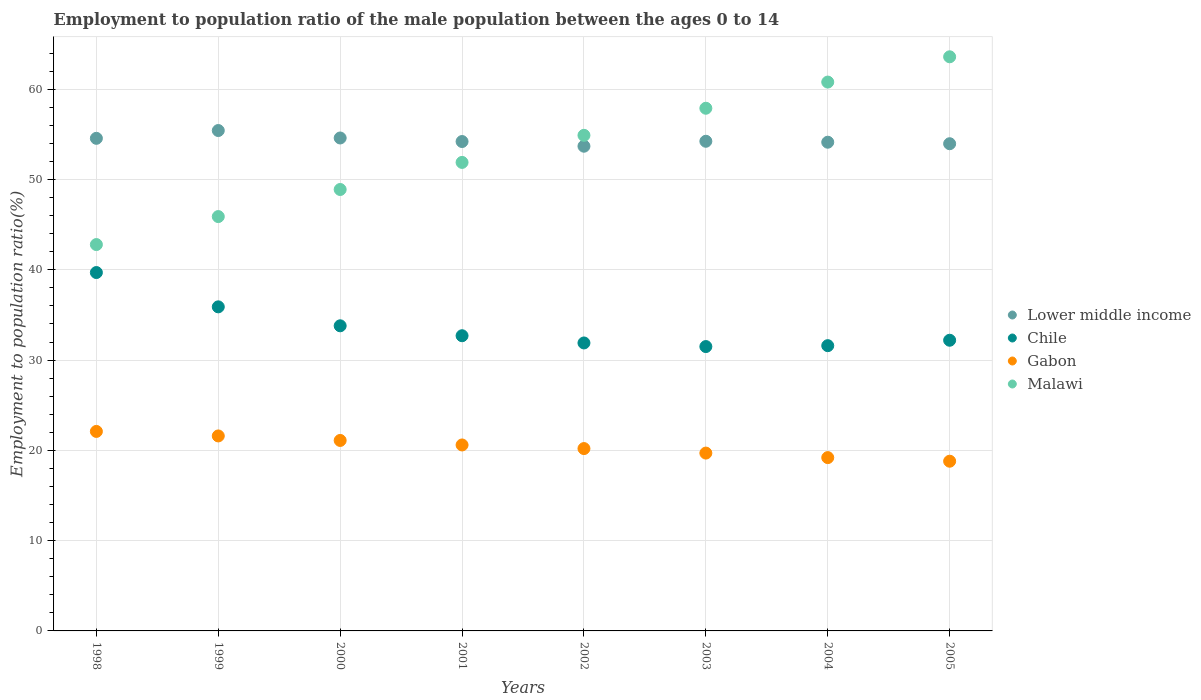How many different coloured dotlines are there?
Offer a very short reply. 4. Is the number of dotlines equal to the number of legend labels?
Keep it short and to the point. Yes. What is the employment to population ratio in Chile in 2002?
Your answer should be very brief. 31.9. Across all years, what is the maximum employment to population ratio in Chile?
Provide a succinct answer. 39.7. Across all years, what is the minimum employment to population ratio in Gabon?
Your response must be concise. 18.8. In which year was the employment to population ratio in Chile maximum?
Provide a short and direct response. 1998. What is the total employment to population ratio in Malawi in the graph?
Give a very brief answer. 426.7. What is the difference between the employment to population ratio in Gabon in 2002 and that in 2005?
Provide a succinct answer. 1.4. What is the difference between the employment to population ratio in Chile in 1999 and the employment to population ratio in Gabon in 2005?
Provide a short and direct response. 17.1. What is the average employment to population ratio in Chile per year?
Your answer should be compact. 33.66. In the year 2002, what is the difference between the employment to population ratio in Lower middle income and employment to population ratio in Gabon?
Keep it short and to the point. 33.49. What is the ratio of the employment to population ratio in Lower middle income in 1999 to that in 2002?
Your response must be concise. 1.03. Is the employment to population ratio in Lower middle income in 1998 less than that in 2001?
Offer a terse response. No. Is the difference between the employment to population ratio in Lower middle income in 1999 and 2001 greater than the difference between the employment to population ratio in Gabon in 1999 and 2001?
Provide a succinct answer. Yes. What is the difference between the highest and the second highest employment to population ratio in Lower middle income?
Your response must be concise. 0.83. What is the difference between the highest and the lowest employment to population ratio in Chile?
Ensure brevity in your answer.  8.2. In how many years, is the employment to population ratio in Chile greater than the average employment to population ratio in Chile taken over all years?
Ensure brevity in your answer.  3. Is it the case that in every year, the sum of the employment to population ratio in Gabon and employment to population ratio in Malawi  is greater than the sum of employment to population ratio in Lower middle income and employment to population ratio in Chile?
Give a very brief answer. Yes. Is it the case that in every year, the sum of the employment to population ratio in Gabon and employment to population ratio in Malawi  is greater than the employment to population ratio in Chile?
Offer a terse response. Yes. Does the employment to population ratio in Malawi monotonically increase over the years?
Keep it short and to the point. Yes. Is the employment to population ratio in Gabon strictly greater than the employment to population ratio in Lower middle income over the years?
Make the answer very short. No. How many dotlines are there?
Provide a succinct answer. 4. How many years are there in the graph?
Provide a short and direct response. 8. Does the graph contain any zero values?
Ensure brevity in your answer.  No. What is the title of the graph?
Ensure brevity in your answer.  Employment to population ratio of the male population between the ages 0 to 14. Does "St. Martin (French part)" appear as one of the legend labels in the graph?
Your response must be concise. No. What is the label or title of the X-axis?
Ensure brevity in your answer.  Years. What is the Employment to population ratio(%) of Lower middle income in 1998?
Give a very brief answer. 54.57. What is the Employment to population ratio(%) in Chile in 1998?
Give a very brief answer. 39.7. What is the Employment to population ratio(%) in Gabon in 1998?
Keep it short and to the point. 22.1. What is the Employment to population ratio(%) of Malawi in 1998?
Provide a succinct answer. 42.8. What is the Employment to population ratio(%) of Lower middle income in 1999?
Offer a terse response. 55.43. What is the Employment to population ratio(%) in Chile in 1999?
Provide a succinct answer. 35.9. What is the Employment to population ratio(%) of Gabon in 1999?
Your answer should be very brief. 21.6. What is the Employment to population ratio(%) in Malawi in 1999?
Offer a very short reply. 45.9. What is the Employment to population ratio(%) in Lower middle income in 2000?
Give a very brief answer. 54.61. What is the Employment to population ratio(%) of Chile in 2000?
Offer a terse response. 33.8. What is the Employment to population ratio(%) in Gabon in 2000?
Your response must be concise. 21.1. What is the Employment to population ratio(%) in Malawi in 2000?
Make the answer very short. 48.9. What is the Employment to population ratio(%) of Lower middle income in 2001?
Offer a terse response. 54.21. What is the Employment to population ratio(%) of Chile in 2001?
Your response must be concise. 32.7. What is the Employment to population ratio(%) in Gabon in 2001?
Keep it short and to the point. 20.6. What is the Employment to population ratio(%) in Malawi in 2001?
Keep it short and to the point. 51.9. What is the Employment to population ratio(%) of Lower middle income in 2002?
Provide a succinct answer. 53.69. What is the Employment to population ratio(%) in Chile in 2002?
Your answer should be very brief. 31.9. What is the Employment to population ratio(%) in Gabon in 2002?
Offer a terse response. 20.2. What is the Employment to population ratio(%) in Malawi in 2002?
Provide a short and direct response. 54.9. What is the Employment to population ratio(%) of Lower middle income in 2003?
Make the answer very short. 54.24. What is the Employment to population ratio(%) of Chile in 2003?
Your answer should be compact. 31.5. What is the Employment to population ratio(%) of Gabon in 2003?
Your answer should be compact. 19.7. What is the Employment to population ratio(%) in Malawi in 2003?
Give a very brief answer. 57.9. What is the Employment to population ratio(%) in Lower middle income in 2004?
Your response must be concise. 54.14. What is the Employment to population ratio(%) of Chile in 2004?
Your answer should be very brief. 31.6. What is the Employment to population ratio(%) in Gabon in 2004?
Your answer should be compact. 19.2. What is the Employment to population ratio(%) in Malawi in 2004?
Provide a succinct answer. 60.8. What is the Employment to population ratio(%) of Lower middle income in 2005?
Your answer should be very brief. 53.97. What is the Employment to population ratio(%) of Chile in 2005?
Give a very brief answer. 32.2. What is the Employment to population ratio(%) of Gabon in 2005?
Offer a very short reply. 18.8. What is the Employment to population ratio(%) in Malawi in 2005?
Provide a short and direct response. 63.6. Across all years, what is the maximum Employment to population ratio(%) of Lower middle income?
Your response must be concise. 55.43. Across all years, what is the maximum Employment to population ratio(%) of Chile?
Provide a succinct answer. 39.7. Across all years, what is the maximum Employment to population ratio(%) in Gabon?
Ensure brevity in your answer.  22.1. Across all years, what is the maximum Employment to population ratio(%) of Malawi?
Make the answer very short. 63.6. Across all years, what is the minimum Employment to population ratio(%) of Lower middle income?
Your answer should be very brief. 53.69. Across all years, what is the minimum Employment to population ratio(%) in Chile?
Make the answer very short. 31.5. Across all years, what is the minimum Employment to population ratio(%) of Gabon?
Your answer should be very brief. 18.8. Across all years, what is the minimum Employment to population ratio(%) in Malawi?
Give a very brief answer. 42.8. What is the total Employment to population ratio(%) in Lower middle income in the graph?
Provide a succinct answer. 434.86. What is the total Employment to population ratio(%) of Chile in the graph?
Provide a short and direct response. 269.3. What is the total Employment to population ratio(%) of Gabon in the graph?
Provide a short and direct response. 163.3. What is the total Employment to population ratio(%) of Malawi in the graph?
Ensure brevity in your answer.  426.7. What is the difference between the Employment to population ratio(%) in Lower middle income in 1998 and that in 1999?
Provide a succinct answer. -0.86. What is the difference between the Employment to population ratio(%) in Chile in 1998 and that in 1999?
Keep it short and to the point. 3.8. What is the difference between the Employment to population ratio(%) of Lower middle income in 1998 and that in 2000?
Keep it short and to the point. -0.04. What is the difference between the Employment to population ratio(%) of Lower middle income in 1998 and that in 2001?
Ensure brevity in your answer.  0.35. What is the difference between the Employment to population ratio(%) in Chile in 1998 and that in 2001?
Provide a short and direct response. 7. What is the difference between the Employment to population ratio(%) of Gabon in 1998 and that in 2001?
Provide a succinct answer. 1.5. What is the difference between the Employment to population ratio(%) of Malawi in 1998 and that in 2001?
Ensure brevity in your answer.  -9.1. What is the difference between the Employment to population ratio(%) in Lower middle income in 1998 and that in 2002?
Your response must be concise. 0.87. What is the difference between the Employment to population ratio(%) of Gabon in 1998 and that in 2002?
Ensure brevity in your answer.  1.9. What is the difference between the Employment to population ratio(%) in Lower middle income in 1998 and that in 2003?
Offer a very short reply. 0.33. What is the difference between the Employment to population ratio(%) of Chile in 1998 and that in 2003?
Provide a succinct answer. 8.2. What is the difference between the Employment to population ratio(%) in Gabon in 1998 and that in 2003?
Offer a very short reply. 2.4. What is the difference between the Employment to population ratio(%) in Malawi in 1998 and that in 2003?
Provide a succinct answer. -15.1. What is the difference between the Employment to population ratio(%) in Lower middle income in 1998 and that in 2004?
Keep it short and to the point. 0.43. What is the difference between the Employment to population ratio(%) of Gabon in 1998 and that in 2004?
Ensure brevity in your answer.  2.9. What is the difference between the Employment to population ratio(%) of Lower middle income in 1998 and that in 2005?
Keep it short and to the point. 0.6. What is the difference between the Employment to population ratio(%) in Malawi in 1998 and that in 2005?
Offer a very short reply. -20.8. What is the difference between the Employment to population ratio(%) in Lower middle income in 1999 and that in 2000?
Keep it short and to the point. 0.83. What is the difference between the Employment to population ratio(%) of Malawi in 1999 and that in 2000?
Provide a short and direct response. -3. What is the difference between the Employment to population ratio(%) in Lower middle income in 1999 and that in 2001?
Give a very brief answer. 1.22. What is the difference between the Employment to population ratio(%) of Gabon in 1999 and that in 2001?
Your response must be concise. 1. What is the difference between the Employment to population ratio(%) of Lower middle income in 1999 and that in 2002?
Ensure brevity in your answer.  1.74. What is the difference between the Employment to population ratio(%) of Chile in 1999 and that in 2002?
Your answer should be compact. 4. What is the difference between the Employment to population ratio(%) in Lower middle income in 1999 and that in 2003?
Make the answer very short. 1.19. What is the difference between the Employment to population ratio(%) of Chile in 1999 and that in 2003?
Keep it short and to the point. 4.4. What is the difference between the Employment to population ratio(%) of Gabon in 1999 and that in 2003?
Your response must be concise. 1.9. What is the difference between the Employment to population ratio(%) of Malawi in 1999 and that in 2003?
Offer a very short reply. -12. What is the difference between the Employment to population ratio(%) in Lower middle income in 1999 and that in 2004?
Give a very brief answer. 1.29. What is the difference between the Employment to population ratio(%) in Chile in 1999 and that in 2004?
Your answer should be very brief. 4.3. What is the difference between the Employment to population ratio(%) of Malawi in 1999 and that in 2004?
Make the answer very short. -14.9. What is the difference between the Employment to population ratio(%) of Lower middle income in 1999 and that in 2005?
Keep it short and to the point. 1.46. What is the difference between the Employment to population ratio(%) in Chile in 1999 and that in 2005?
Your answer should be very brief. 3.7. What is the difference between the Employment to population ratio(%) in Malawi in 1999 and that in 2005?
Keep it short and to the point. -17.7. What is the difference between the Employment to population ratio(%) in Lower middle income in 2000 and that in 2001?
Keep it short and to the point. 0.39. What is the difference between the Employment to population ratio(%) in Malawi in 2000 and that in 2001?
Offer a very short reply. -3. What is the difference between the Employment to population ratio(%) in Lower middle income in 2000 and that in 2002?
Make the answer very short. 0.91. What is the difference between the Employment to population ratio(%) in Gabon in 2000 and that in 2002?
Your response must be concise. 0.9. What is the difference between the Employment to population ratio(%) in Malawi in 2000 and that in 2002?
Your answer should be very brief. -6. What is the difference between the Employment to population ratio(%) of Lower middle income in 2000 and that in 2003?
Your answer should be compact. 0.36. What is the difference between the Employment to population ratio(%) in Gabon in 2000 and that in 2003?
Your answer should be very brief. 1.4. What is the difference between the Employment to population ratio(%) in Malawi in 2000 and that in 2003?
Make the answer very short. -9. What is the difference between the Employment to population ratio(%) in Lower middle income in 2000 and that in 2004?
Make the answer very short. 0.47. What is the difference between the Employment to population ratio(%) of Chile in 2000 and that in 2004?
Your answer should be very brief. 2.2. What is the difference between the Employment to population ratio(%) in Lower middle income in 2000 and that in 2005?
Your answer should be very brief. 0.64. What is the difference between the Employment to population ratio(%) of Chile in 2000 and that in 2005?
Give a very brief answer. 1.6. What is the difference between the Employment to population ratio(%) in Gabon in 2000 and that in 2005?
Ensure brevity in your answer.  2.3. What is the difference between the Employment to population ratio(%) of Malawi in 2000 and that in 2005?
Give a very brief answer. -14.7. What is the difference between the Employment to population ratio(%) of Lower middle income in 2001 and that in 2002?
Ensure brevity in your answer.  0.52. What is the difference between the Employment to population ratio(%) of Lower middle income in 2001 and that in 2003?
Give a very brief answer. -0.03. What is the difference between the Employment to population ratio(%) of Chile in 2001 and that in 2003?
Offer a very short reply. 1.2. What is the difference between the Employment to population ratio(%) in Gabon in 2001 and that in 2003?
Your answer should be compact. 0.9. What is the difference between the Employment to population ratio(%) of Lower middle income in 2001 and that in 2004?
Make the answer very short. 0.08. What is the difference between the Employment to population ratio(%) of Chile in 2001 and that in 2004?
Offer a terse response. 1.1. What is the difference between the Employment to population ratio(%) of Gabon in 2001 and that in 2004?
Offer a very short reply. 1.4. What is the difference between the Employment to population ratio(%) in Malawi in 2001 and that in 2004?
Give a very brief answer. -8.9. What is the difference between the Employment to population ratio(%) in Lower middle income in 2001 and that in 2005?
Your response must be concise. 0.24. What is the difference between the Employment to population ratio(%) in Chile in 2001 and that in 2005?
Provide a succinct answer. 0.5. What is the difference between the Employment to population ratio(%) in Lower middle income in 2002 and that in 2003?
Your answer should be very brief. -0.55. What is the difference between the Employment to population ratio(%) in Lower middle income in 2002 and that in 2004?
Your answer should be very brief. -0.44. What is the difference between the Employment to population ratio(%) of Malawi in 2002 and that in 2004?
Your answer should be compact. -5.9. What is the difference between the Employment to population ratio(%) of Lower middle income in 2002 and that in 2005?
Offer a terse response. -0.28. What is the difference between the Employment to population ratio(%) in Chile in 2002 and that in 2005?
Provide a short and direct response. -0.3. What is the difference between the Employment to population ratio(%) in Gabon in 2002 and that in 2005?
Provide a short and direct response. 1.4. What is the difference between the Employment to population ratio(%) in Malawi in 2002 and that in 2005?
Give a very brief answer. -8.7. What is the difference between the Employment to population ratio(%) of Lower middle income in 2003 and that in 2004?
Your answer should be compact. 0.1. What is the difference between the Employment to population ratio(%) of Malawi in 2003 and that in 2004?
Provide a succinct answer. -2.9. What is the difference between the Employment to population ratio(%) in Lower middle income in 2003 and that in 2005?
Give a very brief answer. 0.27. What is the difference between the Employment to population ratio(%) in Gabon in 2003 and that in 2005?
Your answer should be very brief. 0.9. What is the difference between the Employment to population ratio(%) in Lower middle income in 2004 and that in 2005?
Your response must be concise. 0.17. What is the difference between the Employment to population ratio(%) in Gabon in 2004 and that in 2005?
Your answer should be compact. 0.4. What is the difference between the Employment to population ratio(%) in Malawi in 2004 and that in 2005?
Offer a terse response. -2.8. What is the difference between the Employment to population ratio(%) in Lower middle income in 1998 and the Employment to population ratio(%) in Chile in 1999?
Provide a succinct answer. 18.67. What is the difference between the Employment to population ratio(%) in Lower middle income in 1998 and the Employment to population ratio(%) in Gabon in 1999?
Provide a succinct answer. 32.97. What is the difference between the Employment to population ratio(%) of Lower middle income in 1998 and the Employment to population ratio(%) of Malawi in 1999?
Keep it short and to the point. 8.67. What is the difference between the Employment to population ratio(%) in Chile in 1998 and the Employment to population ratio(%) in Malawi in 1999?
Offer a terse response. -6.2. What is the difference between the Employment to population ratio(%) in Gabon in 1998 and the Employment to population ratio(%) in Malawi in 1999?
Give a very brief answer. -23.8. What is the difference between the Employment to population ratio(%) in Lower middle income in 1998 and the Employment to population ratio(%) in Chile in 2000?
Give a very brief answer. 20.77. What is the difference between the Employment to population ratio(%) in Lower middle income in 1998 and the Employment to population ratio(%) in Gabon in 2000?
Your answer should be compact. 33.47. What is the difference between the Employment to population ratio(%) in Lower middle income in 1998 and the Employment to population ratio(%) in Malawi in 2000?
Your answer should be very brief. 5.67. What is the difference between the Employment to population ratio(%) in Chile in 1998 and the Employment to population ratio(%) in Malawi in 2000?
Offer a very short reply. -9.2. What is the difference between the Employment to population ratio(%) of Gabon in 1998 and the Employment to population ratio(%) of Malawi in 2000?
Offer a very short reply. -26.8. What is the difference between the Employment to population ratio(%) in Lower middle income in 1998 and the Employment to population ratio(%) in Chile in 2001?
Provide a short and direct response. 21.87. What is the difference between the Employment to population ratio(%) of Lower middle income in 1998 and the Employment to population ratio(%) of Gabon in 2001?
Provide a short and direct response. 33.97. What is the difference between the Employment to population ratio(%) of Lower middle income in 1998 and the Employment to population ratio(%) of Malawi in 2001?
Give a very brief answer. 2.67. What is the difference between the Employment to population ratio(%) of Chile in 1998 and the Employment to population ratio(%) of Malawi in 2001?
Provide a succinct answer. -12.2. What is the difference between the Employment to population ratio(%) of Gabon in 1998 and the Employment to population ratio(%) of Malawi in 2001?
Ensure brevity in your answer.  -29.8. What is the difference between the Employment to population ratio(%) of Lower middle income in 1998 and the Employment to population ratio(%) of Chile in 2002?
Your answer should be compact. 22.67. What is the difference between the Employment to population ratio(%) of Lower middle income in 1998 and the Employment to population ratio(%) of Gabon in 2002?
Give a very brief answer. 34.37. What is the difference between the Employment to population ratio(%) in Lower middle income in 1998 and the Employment to population ratio(%) in Malawi in 2002?
Provide a short and direct response. -0.33. What is the difference between the Employment to population ratio(%) of Chile in 1998 and the Employment to population ratio(%) of Gabon in 2002?
Your response must be concise. 19.5. What is the difference between the Employment to population ratio(%) in Chile in 1998 and the Employment to population ratio(%) in Malawi in 2002?
Your answer should be very brief. -15.2. What is the difference between the Employment to population ratio(%) in Gabon in 1998 and the Employment to population ratio(%) in Malawi in 2002?
Offer a very short reply. -32.8. What is the difference between the Employment to population ratio(%) in Lower middle income in 1998 and the Employment to population ratio(%) in Chile in 2003?
Provide a succinct answer. 23.07. What is the difference between the Employment to population ratio(%) in Lower middle income in 1998 and the Employment to population ratio(%) in Gabon in 2003?
Ensure brevity in your answer.  34.87. What is the difference between the Employment to population ratio(%) in Lower middle income in 1998 and the Employment to population ratio(%) in Malawi in 2003?
Provide a short and direct response. -3.33. What is the difference between the Employment to population ratio(%) in Chile in 1998 and the Employment to population ratio(%) in Malawi in 2003?
Ensure brevity in your answer.  -18.2. What is the difference between the Employment to population ratio(%) of Gabon in 1998 and the Employment to population ratio(%) of Malawi in 2003?
Provide a short and direct response. -35.8. What is the difference between the Employment to population ratio(%) in Lower middle income in 1998 and the Employment to population ratio(%) in Chile in 2004?
Provide a short and direct response. 22.97. What is the difference between the Employment to population ratio(%) in Lower middle income in 1998 and the Employment to population ratio(%) in Gabon in 2004?
Offer a terse response. 35.37. What is the difference between the Employment to population ratio(%) of Lower middle income in 1998 and the Employment to population ratio(%) of Malawi in 2004?
Your answer should be very brief. -6.23. What is the difference between the Employment to population ratio(%) of Chile in 1998 and the Employment to population ratio(%) of Malawi in 2004?
Offer a very short reply. -21.1. What is the difference between the Employment to population ratio(%) in Gabon in 1998 and the Employment to population ratio(%) in Malawi in 2004?
Your answer should be compact. -38.7. What is the difference between the Employment to population ratio(%) in Lower middle income in 1998 and the Employment to population ratio(%) in Chile in 2005?
Provide a short and direct response. 22.37. What is the difference between the Employment to population ratio(%) in Lower middle income in 1998 and the Employment to population ratio(%) in Gabon in 2005?
Offer a very short reply. 35.77. What is the difference between the Employment to population ratio(%) in Lower middle income in 1998 and the Employment to population ratio(%) in Malawi in 2005?
Give a very brief answer. -9.03. What is the difference between the Employment to population ratio(%) in Chile in 1998 and the Employment to population ratio(%) in Gabon in 2005?
Your response must be concise. 20.9. What is the difference between the Employment to population ratio(%) in Chile in 1998 and the Employment to population ratio(%) in Malawi in 2005?
Your answer should be compact. -23.9. What is the difference between the Employment to population ratio(%) in Gabon in 1998 and the Employment to population ratio(%) in Malawi in 2005?
Keep it short and to the point. -41.5. What is the difference between the Employment to population ratio(%) of Lower middle income in 1999 and the Employment to population ratio(%) of Chile in 2000?
Your answer should be compact. 21.63. What is the difference between the Employment to population ratio(%) of Lower middle income in 1999 and the Employment to population ratio(%) of Gabon in 2000?
Make the answer very short. 34.33. What is the difference between the Employment to population ratio(%) of Lower middle income in 1999 and the Employment to population ratio(%) of Malawi in 2000?
Your response must be concise. 6.53. What is the difference between the Employment to population ratio(%) in Chile in 1999 and the Employment to population ratio(%) in Gabon in 2000?
Your answer should be very brief. 14.8. What is the difference between the Employment to population ratio(%) in Chile in 1999 and the Employment to population ratio(%) in Malawi in 2000?
Offer a terse response. -13. What is the difference between the Employment to population ratio(%) of Gabon in 1999 and the Employment to population ratio(%) of Malawi in 2000?
Offer a terse response. -27.3. What is the difference between the Employment to population ratio(%) in Lower middle income in 1999 and the Employment to population ratio(%) in Chile in 2001?
Your answer should be compact. 22.73. What is the difference between the Employment to population ratio(%) in Lower middle income in 1999 and the Employment to population ratio(%) in Gabon in 2001?
Provide a short and direct response. 34.83. What is the difference between the Employment to population ratio(%) of Lower middle income in 1999 and the Employment to population ratio(%) of Malawi in 2001?
Your answer should be compact. 3.53. What is the difference between the Employment to population ratio(%) of Gabon in 1999 and the Employment to population ratio(%) of Malawi in 2001?
Ensure brevity in your answer.  -30.3. What is the difference between the Employment to population ratio(%) of Lower middle income in 1999 and the Employment to population ratio(%) of Chile in 2002?
Make the answer very short. 23.53. What is the difference between the Employment to population ratio(%) in Lower middle income in 1999 and the Employment to population ratio(%) in Gabon in 2002?
Offer a terse response. 35.23. What is the difference between the Employment to population ratio(%) of Lower middle income in 1999 and the Employment to population ratio(%) of Malawi in 2002?
Give a very brief answer. 0.53. What is the difference between the Employment to population ratio(%) of Chile in 1999 and the Employment to population ratio(%) of Malawi in 2002?
Your answer should be very brief. -19. What is the difference between the Employment to population ratio(%) in Gabon in 1999 and the Employment to population ratio(%) in Malawi in 2002?
Offer a terse response. -33.3. What is the difference between the Employment to population ratio(%) in Lower middle income in 1999 and the Employment to population ratio(%) in Chile in 2003?
Offer a terse response. 23.93. What is the difference between the Employment to population ratio(%) of Lower middle income in 1999 and the Employment to population ratio(%) of Gabon in 2003?
Provide a succinct answer. 35.73. What is the difference between the Employment to population ratio(%) of Lower middle income in 1999 and the Employment to population ratio(%) of Malawi in 2003?
Make the answer very short. -2.47. What is the difference between the Employment to population ratio(%) in Gabon in 1999 and the Employment to population ratio(%) in Malawi in 2003?
Your answer should be very brief. -36.3. What is the difference between the Employment to population ratio(%) in Lower middle income in 1999 and the Employment to population ratio(%) in Chile in 2004?
Offer a terse response. 23.83. What is the difference between the Employment to population ratio(%) in Lower middle income in 1999 and the Employment to population ratio(%) in Gabon in 2004?
Offer a terse response. 36.23. What is the difference between the Employment to population ratio(%) in Lower middle income in 1999 and the Employment to population ratio(%) in Malawi in 2004?
Offer a very short reply. -5.37. What is the difference between the Employment to population ratio(%) of Chile in 1999 and the Employment to population ratio(%) of Malawi in 2004?
Keep it short and to the point. -24.9. What is the difference between the Employment to population ratio(%) in Gabon in 1999 and the Employment to population ratio(%) in Malawi in 2004?
Your answer should be very brief. -39.2. What is the difference between the Employment to population ratio(%) in Lower middle income in 1999 and the Employment to population ratio(%) in Chile in 2005?
Ensure brevity in your answer.  23.23. What is the difference between the Employment to population ratio(%) of Lower middle income in 1999 and the Employment to population ratio(%) of Gabon in 2005?
Keep it short and to the point. 36.63. What is the difference between the Employment to population ratio(%) of Lower middle income in 1999 and the Employment to population ratio(%) of Malawi in 2005?
Keep it short and to the point. -8.17. What is the difference between the Employment to population ratio(%) in Chile in 1999 and the Employment to population ratio(%) in Malawi in 2005?
Offer a very short reply. -27.7. What is the difference between the Employment to population ratio(%) of Gabon in 1999 and the Employment to population ratio(%) of Malawi in 2005?
Give a very brief answer. -42. What is the difference between the Employment to population ratio(%) in Lower middle income in 2000 and the Employment to population ratio(%) in Chile in 2001?
Offer a very short reply. 21.91. What is the difference between the Employment to population ratio(%) in Lower middle income in 2000 and the Employment to population ratio(%) in Gabon in 2001?
Make the answer very short. 34.01. What is the difference between the Employment to population ratio(%) of Lower middle income in 2000 and the Employment to population ratio(%) of Malawi in 2001?
Offer a very short reply. 2.71. What is the difference between the Employment to population ratio(%) in Chile in 2000 and the Employment to population ratio(%) in Gabon in 2001?
Ensure brevity in your answer.  13.2. What is the difference between the Employment to population ratio(%) in Chile in 2000 and the Employment to population ratio(%) in Malawi in 2001?
Your answer should be compact. -18.1. What is the difference between the Employment to population ratio(%) in Gabon in 2000 and the Employment to population ratio(%) in Malawi in 2001?
Keep it short and to the point. -30.8. What is the difference between the Employment to population ratio(%) of Lower middle income in 2000 and the Employment to population ratio(%) of Chile in 2002?
Offer a very short reply. 22.71. What is the difference between the Employment to population ratio(%) of Lower middle income in 2000 and the Employment to population ratio(%) of Gabon in 2002?
Provide a succinct answer. 34.41. What is the difference between the Employment to population ratio(%) of Lower middle income in 2000 and the Employment to population ratio(%) of Malawi in 2002?
Your answer should be compact. -0.29. What is the difference between the Employment to population ratio(%) in Chile in 2000 and the Employment to population ratio(%) in Malawi in 2002?
Offer a terse response. -21.1. What is the difference between the Employment to population ratio(%) of Gabon in 2000 and the Employment to population ratio(%) of Malawi in 2002?
Provide a short and direct response. -33.8. What is the difference between the Employment to population ratio(%) of Lower middle income in 2000 and the Employment to population ratio(%) of Chile in 2003?
Make the answer very short. 23.11. What is the difference between the Employment to population ratio(%) in Lower middle income in 2000 and the Employment to population ratio(%) in Gabon in 2003?
Keep it short and to the point. 34.91. What is the difference between the Employment to population ratio(%) of Lower middle income in 2000 and the Employment to population ratio(%) of Malawi in 2003?
Provide a short and direct response. -3.29. What is the difference between the Employment to population ratio(%) of Chile in 2000 and the Employment to population ratio(%) of Gabon in 2003?
Keep it short and to the point. 14.1. What is the difference between the Employment to population ratio(%) of Chile in 2000 and the Employment to population ratio(%) of Malawi in 2003?
Keep it short and to the point. -24.1. What is the difference between the Employment to population ratio(%) in Gabon in 2000 and the Employment to population ratio(%) in Malawi in 2003?
Ensure brevity in your answer.  -36.8. What is the difference between the Employment to population ratio(%) of Lower middle income in 2000 and the Employment to population ratio(%) of Chile in 2004?
Offer a very short reply. 23.01. What is the difference between the Employment to population ratio(%) in Lower middle income in 2000 and the Employment to population ratio(%) in Gabon in 2004?
Your answer should be very brief. 35.41. What is the difference between the Employment to population ratio(%) in Lower middle income in 2000 and the Employment to population ratio(%) in Malawi in 2004?
Your response must be concise. -6.19. What is the difference between the Employment to population ratio(%) of Chile in 2000 and the Employment to population ratio(%) of Gabon in 2004?
Your answer should be very brief. 14.6. What is the difference between the Employment to population ratio(%) of Gabon in 2000 and the Employment to population ratio(%) of Malawi in 2004?
Make the answer very short. -39.7. What is the difference between the Employment to population ratio(%) of Lower middle income in 2000 and the Employment to population ratio(%) of Chile in 2005?
Offer a terse response. 22.41. What is the difference between the Employment to population ratio(%) in Lower middle income in 2000 and the Employment to population ratio(%) in Gabon in 2005?
Offer a very short reply. 35.81. What is the difference between the Employment to population ratio(%) in Lower middle income in 2000 and the Employment to population ratio(%) in Malawi in 2005?
Offer a terse response. -8.99. What is the difference between the Employment to population ratio(%) of Chile in 2000 and the Employment to population ratio(%) of Malawi in 2005?
Offer a very short reply. -29.8. What is the difference between the Employment to population ratio(%) of Gabon in 2000 and the Employment to population ratio(%) of Malawi in 2005?
Provide a succinct answer. -42.5. What is the difference between the Employment to population ratio(%) in Lower middle income in 2001 and the Employment to population ratio(%) in Chile in 2002?
Ensure brevity in your answer.  22.31. What is the difference between the Employment to population ratio(%) of Lower middle income in 2001 and the Employment to population ratio(%) of Gabon in 2002?
Your response must be concise. 34.01. What is the difference between the Employment to population ratio(%) of Lower middle income in 2001 and the Employment to population ratio(%) of Malawi in 2002?
Offer a terse response. -0.69. What is the difference between the Employment to population ratio(%) of Chile in 2001 and the Employment to population ratio(%) of Gabon in 2002?
Keep it short and to the point. 12.5. What is the difference between the Employment to population ratio(%) of Chile in 2001 and the Employment to population ratio(%) of Malawi in 2002?
Keep it short and to the point. -22.2. What is the difference between the Employment to population ratio(%) in Gabon in 2001 and the Employment to population ratio(%) in Malawi in 2002?
Give a very brief answer. -34.3. What is the difference between the Employment to population ratio(%) of Lower middle income in 2001 and the Employment to population ratio(%) of Chile in 2003?
Offer a very short reply. 22.71. What is the difference between the Employment to population ratio(%) in Lower middle income in 2001 and the Employment to population ratio(%) in Gabon in 2003?
Your response must be concise. 34.51. What is the difference between the Employment to population ratio(%) in Lower middle income in 2001 and the Employment to population ratio(%) in Malawi in 2003?
Offer a terse response. -3.69. What is the difference between the Employment to population ratio(%) in Chile in 2001 and the Employment to population ratio(%) in Gabon in 2003?
Ensure brevity in your answer.  13. What is the difference between the Employment to population ratio(%) of Chile in 2001 and the Employment to population ratio(%) of Malawi in 2003?
Your answer should be compact. -25.2. What is the difference between the Employment to population ratio(%) in Gabon in 2001 and the Employment to population ratio(%) in Malawi in 2003?
Your response must be concise. -37.3. What is the difference between the Employment to population ratio(%) in Lower middle income in 2001 and the Employment to population ratio(%) in Chile in 2004?
Keep it short and to the point. 22.61. What is the difference between the Employment to population ratio(%) in Lower middle income in 2001 and the Employment to population ratio(%) in Gabon in 2004?
Provide a short and direct response. 35.01. What is the difference between the Employment to population ratio(%) of Lower middle income in 2001 and the Employment to population ratio(%) of Malawi in 2004?
Provide a short and direct response. -6.59. What is the difference between the Employment to population ratio(%) in Chile in 2001 and the Employment to population ratio(%) in Gabon in 2004?
Your answer should be very brief. 13.5. What is the difference between the Employment to population ratio(%) of Chile in 2001 and the Employment to population ratio(%) of Malawi in 2004?
Your response must be concise. -28.1. What is the difference between the Employment to population ratio(%) in Gabon in 2001 and the Employment to population ratio(%) in Malawi in 2004?
Keep it short and to the point. -40.2. What is the difference between the Employment to population ratio(%) in Lower middle income in 2001 and the Employment to population ratio(%) in Chile in 2005?
Your response must be concise. 22.01. What is the difference between the Employment to population ratio(%) in Lower middle income in 2001 and the Employment to population ratio(%) in Gabon in 2005?
Your answer should be very brief. 35.41. What is the difference between the Employment to population ratio(%) of Lower middle income in 2001 and the Employment to population ratio(%) of Malawi in 2005?
Your answer should be very brief. -9.39. What is the difference between the Employment to population ratio(%) of Chile in 2001 and the Employment to population ratio(%) of Gabon in 2005?
Your response must be concise. 13.9. What is the difference between the Employment to population ratio(%) in Chile in 2001 and the Employment to population ratio(%) in Malawi in 2005?
Ensure brevity in your answer.  -30.9. What is the difference between the Employment to population ratio(%) of Gabon in 2001 and the Employment to population ratio(%) of Malawi in 2005?
Offer a very short reply. -43. What is the difference between the Employment to population ratio(%) of Lower middle income in 2002 and the Employment to population ratio(%) of Chile in 2003?
Provide a short and direct response. 22.19. What is the difference between the Employment to population ratio(%) of Lower middle income in 2002 and the Employment to population ratio(%) of Gabon in 2003?
Ensure brevity in your answer.  33.99. What is the difference between the Employment to population ratio(%) in Lower middle income in 2002 and the Employment to population ratio(%) in Malawi in 2003?
Your answer should be very brief. -4.21. What is the difference between the Employment to population ratio(%) of Gabon in 2002 and the Employment to population ratio(%) of Malawi in 2003?
Give a very brief answer. -37.7. What is the difference between the Employment to population ratio(%) of Lower middle income in 2002 and the Employment to population ratio(%) of Chile in 2004?
Offer a terse response. 22.09. What is the difference between the Employment to population ratio(%) of Lower middle income in 2002 and the Employment to population ratio(%) of Gabon in 2004?
Offer a very short reply. 34.49. What is the difference between the Employment to population ratio(%) of Lower middle income in 2002 and the Employment to population ratio(%) of Malawi in 2004?
Keep it short and to the point. -7.11. What is the difference between the Employment to population ratio(%) in Chile in 2002 and the Employment to population ratio(%) in Gabon in 2004?
Your answer should be very brief. 12.7. What is the difference between the Employment to population ratio(%) in Chile in 2002 and the Employment to population ratio(%) in Malawi in 2004?
Your answer should be very brief. -28.9. What is the difference between the Employment to population ratio(%) of Gabon in 2002 and the Employment to population ratio(%) of Malawi in 2004?
Make the answer very short. -40.6. What is the difference between the Employment to population ratio(%) of Lower middle income in 2002 and the Employment to population ratio(%) of Chile in 2005?
Offer a very short reply. 21.49. What is the difference between the Employment to population ratio(%) of Lower middle income in 2002 and the Employment to population ratio(%) of Gabon in 2005?
Ensure brevity in your answer.  34.89. What is the difference between the Employment to population ratio(%) of Lower middle income in 2002 and the Employment to population ratio(%) of Malawi in 2005?
Ensure brevity in your answer.  -9.91. What is the difference between the Employment to population ratio(%) in Chile in 2002 and the Employment to population ratio(%) in Malawi in 2005?
Your answer should be very brief. -31.7. What is the difference between the Employment to population ratio(%) of Gabon in 2002 and the Employment to population ratio(%) of Malawi in 2005?
Give a very brief answer. -43.4. What is the difference between the Employment to population ratio(%) in Lower middle income in 2003 and the Employment to population ratio(%) in Chile in 2004?
Your answer should be very brief. 22.64. What is the difference between the Employment to population ratio(%) in Lower middle income in 2003 and the Employment to population ratio(%) in Gabon in 2004?
Provide a short and direct response. 35.04. What is the difference between the Employment to population ratio(%) of Lower middle income in 2003 and the Employment to population ratio(%) of Malawi in 2004?
Give a very brief answer. -6.56. What is the difference between the Employment to population ratio(%) in Chile in 2003 and the Employment to population ratio(%) in Gabon in 2004?
Ensure brevity in your answer.  12.3. What is the difference between the Employment to population ratio(%) of Chile in 2003 and the Employment to population ratio(%) of Malawi in 2004?
Provide a succinct answer. -29.3. What is the difference between the Employment to population ratio(%) of Gabon in 2003 and the Employment to population ratio(%) of Malawi in 2004?
Your answer should be compact. -41.1. What is the difference between the Employment to population ratio(%) of Lower middle income in 2003 and the Employment to population ratio(%) of Chile in 2005?
Provide a succinct answer. 22.04. What is the difference between the Employment to population ratio(%) of Lower middle income in 2003 and the Employment to population ratio(%) of Gabon in 2005?
Provide a succinct answer. 35.44. What is the difference between the Employment to population ratio(%) in Lower middle income in 2003 and the Employment to population ratio(%) in Malawi in 2005?
Your response must be concise. -9.36. What is the difference between the Employment to population ratio(%) of Chile in 2003 and the Employment to population ratio(%) of Malawi in 2005?
Provide a succinct answer. -32.1. What is the difference between the Employment to population ratio(%) of Gabon in 2003 and the Employment to population ratio(%) of Malawi in 2005?
Offer a terse response. -43.9. What is the difference between the Employment to population ratio(%) in Lower middle income in 2004 and the Employment to population ratio(%) in Chile in 2005?
Offer a terse response. 21.94. What is the difference between the Employment to population ratio(%) in Lower middle income in 2004 and the Employment to population ratio(%) in Gabon in 2005?
Keep it short and to the point. 35.34. What is the difference between the Employment to population ratio(%) in Lower middle income in 2004 and the Employment to population ratio(%) in Malawi in 2005?
Provide a short and direct response. -9.46. What is the difference between the Employment to population ratio(%) of Chile in 2004 and the Employment to population ratio(%) of Gabon in 2005?
Provide a short and direct response. 12.8. What is the difference between the Employment to population ratio(%) in Chile in 2004 and the Employment to population ratio(%) in Malawi in 2005?
Provide a short and direct response. -32. What is the difference between the Employment to population ratio(%) in Gabon in 2004 and the Employment to population ratio(%) in Malawi in 2005?
Your response must be concise. -44.4. What is the average Employment to population ratio(%) of Lower middle income per year?
Offer a terse response. 54.36. What is the average Employment to population ratio(%) in Chile per year?
Ensure brevity in your answer.  33.66. What is the average Employment to population ratio(%) of Gabon per year?
Offer a terse response. 20.41. What is the average Employment to population ratio(%) in Malawi per year?
Your answer should be compact. 53.34. In the year 1998, what is the difference between the Employment to population ratio(%) in Lower middle income and Employment to population ratio(%) in Chile?
Give a very brief answer. 14.87. In the year 1998, what is the difference between the Employment to population ratio(%) of Lower middle income and Employment to population ratio(%) of Gabon?
Your response must be concise. 32.47. In the year 1998, what is the difference between the Employment to population ratio(%) in Lower middle income and Employment to population ratio(%) in Malawi?
Your answer should be compact. 11.77. In the year 1998, what is the difference between the Employment to population ratio(%) in Chile and Employment to population ratio(%) in Gabon?
Provide a short and direct response. 17.6. In the year 1998, what is the difference between the Employment to population ratio(%) in Chile and Employment to population ratio(%) in Malawi?
Your response must be concise. -3.1. In the year 1998, what is the difference between the Employment to population ratio(%) of Gabon and Employment to population ratio(%) of Malawi?
Give a very brief answer. -20.7. In the year 1999, what is the difference between the Employment to population ratio(%) in Lower middle income and Employment to population ratio(%) in Chile?
Offer a very short reply. 19.53. In the year 1999, what is the difference between the Employment to population ratio(%) of Lower middle income and Employment to population ratio(%) of Gabon?
Offer a terse response. 33.83. In the year 1999, what is the difference between the Employment to population ratio(%) of Lower middle income and Employment to population ratio(%) of Malawi?
Offer a very short reply. 9.53. In the year 1999, what is the difference between the Employment to population ratio(%) in Gabon and Employment to population ratio(%) in Malawi?
Provide a succinct answer. -24.3. In the year 2000, what is the difference between the Employment to population ratio(%) in Lower middle income and Employment to population ratio(%) in Chile?
Ensure brevity in your answer.  20.81. In the year 2000, what is the difference between the Employment to population ratio(%) of Lower middle income and Employment to population ratio(%) of Gabon?
Offer a terse response. 33.51. In the year 2000, what is the difference between the Employment to population ratio(%) in Lower middle income and Employment to population ratio(%) in Malawi?
Your answer should be compact. 5.71. In the year 2000, what is the difference between the Employment to population ratio(%) of Chile and Employment to population ratio(%) of Malawi?
Make the answer very short. -15.1. In the year 2000, what is the difference between the Employment to population ratio(%) of Gabon and Employment to population ratio(%) of Malawi?
Your response must be concise. -27.8. In the year 2001, what is the difference between the Employment to population ratio(%) of Lower middle income and Employment to population ratio(%) of Chile?
Provide a short and direct response. 21.51. In the year 2001, what is the difference between the Employment to population ratio(%) of Lower middle income and Employment to population ratio(%) of Gabon?
Your answer should be very brief. 33.61. In the year 2001, what is the difference between the Employment to population ratio(%) in Lower middle income and Employment to population ratio(%) in Malawi?
Make the answer very short. 2.31. In the year 2001, what is the difference between the Employment to population ratio(%) of Chile and Employment to population ratio(%) of Gabon?
Your response must be concise. 12.1. In the year 2001, what is the difference between the Employment to population ratio(%) of Chile and Employment to population ratio(%) of Malawi?
Offer a terse response. -19.2. In the year 2001, what is the difference between the Employment to population ratio(%) in Gabon and Employment to population ratio(%) in Malawi?
Your answer should be compact. -31.3. In the year 2002, what is the difference between the Employment to population ratio(%) in Lower middle income and Employment to population ratio(%) in Chile?
Ensure brevity in your answer.  21.79. In the year 2002, what is the difference between the Employment to population ratio(%) of Lower middle income and Employment to population ratio(%) of Gabon?
Offer a terse response. 33.49. In the year 2002, what is the difference between the Employment to population ratio(%) in Lower middle income and Employment to population ratio(%) in Malawi?
Keep it short and to the point. -1.21. In the year 2002, what is the difference between the Employment to population ratio(%) of Chile and Employment to population ratio(%) of Malawi?
Keep it short and to the point. -23. In the year 2002, what is the difference between the Employment to population ratio(%) in Gabon and Employment to population ratio(%) in Malawi?
Offer a terse response. -34.7. In the year 2003, what is the difference between the Employment to population ratio(%) of Lower middle income and Employment to population ratio(%) of Chile?
Your answer should be very brief. 22.74. In the year 2003, what is the difference between the Employment to population ratio(%) in Lower middle income and Employment to population ratio(%) in Gabon?
Ensure brevity in your answer.  34.54. In the year 2003, what is the difference between the Employment to population ratio(%) of Lower middle income and Employment to population ratio(%) of Malawi?
Provide a short and direct response. -3.66. In the year 2003, what is the difference between the Employment to population ratio(%) in Chile and Employment to population ratio(%) in Gabon?
Make the answer very short. 11.8. In the year 2003, what is the difference between the Employment to population ratio(%) of Chile and Employment to population ratio(%) of Malawi?
Offer a terse response. -26.4. In the year 2003, what is the difference between the Employment to population ratio(%) of Gabon and Employment to population ratio(%) of Malawi?
Offer a terse response. -38.2. In the year 2004, what is the difference between the Employment to population ratio(%) in Lower middle income and Employment to population ratio(%) in Chile?
Your answer should be compact. 22.54. In the year 2004, what is the difference between the Employment to population ratio(%) of Lower middle income and Employment to population ratio(%) of Gabon?
Keep it short and to the point. 34.94. In the year 2004, what is the difference between the Employment to population ratio(%) of Lower middle income and Employment to population ratio(%) of Malawi?
Provide a short and direct response. -6.66. In the year 2004, what is the difference between the Employment to population ratio(%) of Chile and Employment to population ratio(%) of Gabon?
Ensure brevity in your answer.  12.4. In the year 2004, what is the difference between the Employment to population ratio(%) of Chile and Employment to population ratio(%) of Malawi?
Ensure brevity in your answer.  -29.2. In the year 2004, what is the difference between the Employment to population ratio(%) in Gabon and Employment to population ratio(%) in Malawi?
Keep it short and to the point. -41.6. In the year 2005, what is the difference between the Employment to population ratio(%) in Lower middle income and Employment to population ratio(%) in Chile?
Your answer should be very brief. 21.77. In the year 2005, what is the difference between the Employment to population ratio(%) in Lower middle income and Employment to population ratio(%) in Gabon?
Give a very brief answer. 35.17. In the year 2005, what is the difference between the Employment to population ratio(%) in Lower middle income and Employment to population ratio(%) in Malawi?
Offer a very short reply. -9.63. In the year 2005, what is the difference between the Employment to population ratio(%) in Chile and Employment to population ratio(%) in Gabon?
Make the answer very short. 13.4. In the year 2005, what is the difference between the Employment to population ratio(%) of Chile and Employment to population ratio(%) of Malawi?
Make the answer very short. -31.4. In the year 2005, what is the difference between the Employment to population ratio(%) of Gabon and Employment to population ratio(%) of Malawi?
Ensure brevity in your answer.  -44.8. What is the ratio of the Employment to population ratio(%) of Lower middle income in 1998 to that in 1999?
Give a very brief answer. 0.98. What is the ratio of the Employment to population ratio(%) in Chile in 1998 to that in 1999?
Make the answer very short. 1.11. What is the ratio of the Employment to population ratio(%) of Gabon in 1998 to that in 1999?
Keep it short and to the point. 1.02. What is the ratio of the Employment to population ratio(%) of Malawi in 1998 to that in 1999?
Provide a succinct answer. 0.93. What is the ratio of the Employment to population ratio(%) of Chile in 1998 to that in 2000?
Ensure brevity in your answer.  1.17. What is the ratio of the Employment to population ratio(%) of Gabon in 1998 to that in 2000?
Your answer should be very brief. 1.05. What is the ratio of the Employment to population ratio(%) of Malawi in 1998 to that in 2000?
Your answer should be compact. 0.88. What is the ratio of the Employment to population ratio(%) of Lower middle income in 1998 to that in 2001?
Offer a very short reply. 1.01. What is the ratio of the Employment to population ratio(%) in Chile in 1998 to that in 2001?
Your answer should be very brief. 1.21. What is the ratio of the Employment to population ratio(%) of Gabon in 1998 to that in 2001?
Ensure brevity in your answer.  1.07. What is the ratio of the Employment to population ratio(%) in Malawi in 1998 to that in 2001?
Give a very brief answer. 0.82. What is the ratio of the Employment to population ratio(%) in Lower middle income in 1998 to that in 2002?
Provide a succinct answer. 1.02. What is the ratio of the Employment to population ratio(%) of Chile in 1998 to that in 2002?
Offer a terse response. 1.24. What is the ratio of the Employment to population ratio(%) in Gabon in 1998 to that in 2002?
Offer a terse response. 1.09. What is the ratio of the Employment to population ratio(%) in Malawi in 1998 to that in 2002?
Your response must be concise. 0.78. What is the ratio of the Employment to population ratio(%) in Chile in 1998 to that in 2003?
Your answer should be very brief. 1.26. What is the ratio of the Employment to population ratio(%) of Gabon in 1998 to that in 2003?
Your answer should be compact. 1.12. What is the ratio of the Employment to population ratio(%) of Malawi in 1998 to that in 2003?
Offer a very short reply. 0.74. What is the ratio of the Employment to population ratio(%) in Lower middle income in 1998 to that in 2004?
Ensure brevity in your answer.  1.01. What is the ratio of the Employment to population ratio(%) in Chile in 1998 to that in 2004?
Your response must be concise. 1.26. What is the ratio of the Employment to population ratio(%) in Gabon in 1998 to that in 2004?
Offer a terse response. 1.15. What is the ratio of the Employment to population ratio(%) in Malawi in 1998 to that in 2004?
Offer a very short reply. 0.7. What is the ratio of the Employment to population ratio(%) of Lower middle income in 1998 to that in 2005?
Your answer should be very brief. 1.01. What is the ratio of the Employment to population ratio(%) in Chile in 1998 to that in 2005?
Keep it short and to the point. 1.23. What is the ratio of the Employment to population ratio(%) of Gabon in 1998 to that in 2005?
Your response must be concise. 1.18. What is the ratio of the Employment to population ratio(%) of Malawi in 1998 to that in 2005?
Your answer should be compact. 0.67. What is the ratio of the Employment to population ratio(%) in Lower middle income in 1999 to that in 2000?
Provide a short and direct response. 1.02. What is the ratio of the Employment to population ratio(%) in Chile in 1999 to that in 2000?
Your answer should be very brief. 1.06. What is the ratio of the Employment to population ratio(%) in Gabon in 1999 to that in 2000?
Ensure brevity in your answer.  1.02. What is the ratio of the Employment to population ratio(%) in Malawi in 1999 to that in 2000?
Offer a very short reply. 0.94. What is the ratio of the Employment to population ratio(%) in Lower middle income in 1999 to that in 2001?
Offer a terse response. 1.02. What is the ratio of the Employment to population ratio(%) in Chile in 1999 to that in 2001?
Offer a terse response. 1.1. What is the ratio of the Employment to population ratio(%) in Gabon in 1999 to that in 2001?
Your response must be concise. 1.05. What is the ratio of the Employment to population ratio(%) of Malawi in 1999 to that in 2001?
Make the answer very short. 0.88. What is the ratio of the Employment to population ratio(%) in Lower middle income in 1999 to that in 2002?
Keep it short and to the point. 1.03. What is the ratio of the Employment to population ratio(%) of Chile in 1999 to that in 2002?
Your answer should be compact. 1.13. What is the ratio of the Employment to population ratio(%) in Gabon in 1999 to that in 2002?
Offer a terse response. 1.07. What is the ratio of the Employment to population ratio(%) in Malawi in 1999 to that in 2002?
Keep it short and to the point. 0.84. What is the ratio of the Employment to population ratio(%) of Lower middle income in 1999 to that in 2003?
Provide a succinct answer. 1.02. What is the ratio of the Employment to population ratio(%) of Chile in 1999 to that in 2003?
Give a very brief answer. 1.14. What is the ratio of the Employment to population ratio(%) in Gabon in 1999 to that in 2003?
Ensure brevity in your answer.  1.1. What is the ratio of the Employment to population ratio(%) of Malawi in 1999 to that in 2003?
Your answer should be very brief. 0.79. What is the ratio of the Employment to population ratio(%) in Lower middle income in 1999 to that in 2004?
Your answer should be compact. 1.02. What is the ratio of the Employment to population ratio(%) of Chile in 1999 to that in 2004?
Give a very brief answer. 1.14. What is the ratio of the Employment to population ratio(%) in Gabon in 1999 to that in 2004?
Your answer should be compact. 1.12. What is the ratio of the Employment to population ratio(%) of Malawi in 1999 to that in 2004?
Provide a succinct answer. 0.75. What is the ratio of the Employment to population ratio(%) in Lower middle income in 1999 to that in 2005?
Provide a short and direct response. 1.03. What is the ratio of the Employment to population ratio(%) of Chile in 1999 to that in 2005?
Offer a terse response. 1.11. What is the ratio of the Employment to population ratio(%) in Gabon in 1999 to that in 2005?
Provide a short and direct response. 1.15. What is the ratio of the Employment to population ratio(%) in Malawi in 1999 to that in 2005?
Your answer should be compact. 0.72. What is the ratio of the Employment to population ratio(%) of Lower middle income in 2000 to that in 2001?
Your answer should be very brief. 1.01. What is the ratio of the Employment to population ratio(%) in Chile in 2000 to that in 2001?
Provide a succinct answer. 1.03. What is the ratio of the Employment to population ratio(%) of Gabon in 2000 to that in 2001?
Keep it short and to the point. 1.02. What is the ratio of the Employment to population ratio(%) in Malawi in 2000 to that in 2001?
Ensure brevity in your answer.  0.94. What is the ratio of the Employment to population ratio(%) in Lower middle income in 2000 to that in 2002?
Offer a very short reply. 1.02. What is the ratio of the Employment to population ratio(%) of Chile in 2000 to that in 2002?
Provide a succinct answer. 1.06. What is the ratio of the Employment to population ratio(%) of Gabon in 2000 to that in 2002?
Your answer should be very brief. 1.04. What is the ratio of the Employment to population ratio(%) of Malawi in 2000 to that in 2002?
Ensure brevity in your answer.  0.89. What is the ratio of the Employment to population ratio(%) of Chile in 2000 to that in 2003?
Keep it short and to the point. 1.07. What is the ratio of the Employment to population ratio(%) in Gabon in 2000 to that in 2003?
Your answer should be very brief. 1.07. What is the ratio of the Employment to population ratio(%) of Malawi in 2000 to that in 2003?
Make the answer very short. 0.84. What is the ratio of the Employment to population ratio(%) in Lower middle income in 2000 to that in 2004?
Your answer should be compact. 1.01. What is the ratio of the Employment to population ratio(%) in Chile in 2000 to that in 2004?
Your answer should be compact. 1.07. What is the ratio of the Employment to population ratio(%) in Gabon in 2000 to that in 2004?
Provide a short and direct response. 1.1. What is the ratio of the Employment to population ratio(%) of Malawi in 2000 to that in 2004?
Your answer should be very brief. 0.8. What is the ratio of the Employment to population ratio(%) in Lower middle income in 2000 to that in 2005?
Provide a succinct answer. 1.01. What is the ratio of the Employment to population ratio(%) in Chile in 2000 to that in 2005?
Give a very brief answer. 1.05. What is the ratio of the Employment to population ratio(%) in Gabon in 2000 to that in 2005?
Your answer should be compact. 1.12. What is the ratio of the Employment to population ratio(%) in Malawi in 2000 to that in 2005?
Provide a succinct answer. 0.77. What is the ratio of the Employment to population ratio(%) of Lower middle income in 2001 to that in 2002?
Give a very brief answer. 1.01. What is the ratio of the Employment to population ratio(%) in Chile in 2001 to that in 2002?
Your response must be concise. 1.03. What is the ratio of the Employment to population ratio(%) of Gabon in 2001 to that in 2002?
Your answer should be compact. 1.02. What is the ratio of the Employment to population ratio(%) of Malawi in 2001 to that in 2002?
Provide a short and direct response. 0.95. What is the ratio of the Employment to population ratio(%) of Lower middle income in 2001 to that in 2003?
Ensure brevity in your answer.  1. What is the ratio of the Employment to population ratio(%) in Chile in 2001 to that in 2003?
Provide a succinct answer. 1.04. What is the ratio of the Employment to population ratio(%) in Gabon in 2001 to that in 2003?
Provide a succinct answer. 1.05. What is the ratio of the Employment to population ratio(%) in Malawi in 2001 to that in 2003?
Ensure brevity in your answer.  0.9. What is the ratio of the Employment to population ratio(%) in Lower middle income in 2001 to that in 2004?
Your answer should be compact. 1. What is the ratio of the Employment to population ratio(%) in Chile in 2001 to that in 2004?
Give a very brief answer. 1.03. What is the ratio of the Employment to population ratio(%) of Gabon in 2001 to that in 2004?
Keep it short and to the point. 1.07. What is the ratio of the Employment to population ratio(%) in Malawi in 2001 to that in 2004?
Provide a succinct answer. 0.85. What is the ratio of the Employment to population ratio(%) in Lower middle income in 2001 to that in 2005?
Offer a very short reply. 1. What is the ratio of the Employment to population ratio(%) of Chile in 2001 to that in 2005?
Keep it short and to the point. 1.02. What is the ratio of the Employment to population ratio(%) of Gabon in 2001 to that in 2005?
Your answer should be compact. 1.1. What is the ratio of the Employment to population ratio(%) in Malawi in 2001 to that in 2005?
Make the answer very short. 0.82. What is the ratio of the Employment to population ratio(%) of Lower middle income in 2002 to that in 2003?
Make the answer very short. 0.99. What is the ratio of the Employment to population ratio(%) of Chile in 2002 to that in 2003?
Provide a succinct answer. 1.01. What is the ratio of the Employment to population ratio(%) in Gabon in 2002 to that in 2003?
Your answer should be very brief. 1.03. What is the ratio of the Employment to population ratio(%) of Malawi in 2002 to that in 2003?
Offer a terse response. 0.95. What is the ratio of the Employment to population ratio(%) in Lower middle income in 2002 to that in 2004?
Your answer should be compact. 0.99. What is the ratio of the Employment to population ratio(%) of Chile in 2002 to that in 2004?
Your answer should be compact. 1.01. What is the ratio of the Employment to population ratio(%) of Gabon in 2002 to that in 2004?
Provide a short and direct response. 1.05. What is the ratio of the Employment to population ratio(%) in Malawi in 2002 to that in 2004?
Give a very brief answer. 0.9. What is the ratio of the Employment to population ratio(%) of Lower middle income in 2002 to that in 2005?
Offer a very short reply. 0.99. What is the ratio of the Employment to population ratio(%) in Chile in 2002 to that in 2005?
Keep it short and to the point. 0.99. What is the ratio of the Employment to population ratio(%) of Gabon in 2002 to that in 2005?
Your response must be concise. 1.07. What is the ratio of the Employment to population ratio(%) of Malawi in 2002 to that in 2005?
Make the answer very short. 0.86. What is the ratio of the Employment to population ratio(%) of Chile in 2003 to that in 2004?
Your answer should be very brief. 1. What is the ratio of the Employment to population ratio(%) of Gabon in 2003 to that in 2004?
Your response must be concise. 1.03. What is the ratio of the Employment to population ratio(%) of Malawi in 2003 to that in 2004?
Make the answer very short. 0.95. What is the ratio of the Employment to population ratio(%) of Lower middle income in 2003 to that in 2005?
Provide a succinct answer. 1. What is the ratio of the Employment to population ratio(%) in Chile in 2003 to that in 2005?
Keep it short and to the point. 0.98. What is the ratio of the Employment to population ratio(%) in Gabon in 2003 to that in 2005?
Provide a succinct answer. 1.05. What is the ratio of the Employment to population ratio(%) in Malawi in 2003 to that in 2005?
Your response must be concise. 0.91. What is the ratio of the Employment to population ratio(%) in Lower middle income in 2004 to that in 2005?
Make the answer very short. 1. What is the ratio of the Employment to population ratio(%) in Chile in 2004 to that in 2005?
Your answer should be compact. 0.98. What is the ratio of the Employment to population ratio(%) of Gabon in 2004 to that in 2005?
Keep it short and to the point. 1.02. What is the ratio of the Employment to population ratio(%) of Malawi in 2004 to that in 2005?
Offer a very short reply. 0.96. What is the difference between the highest and the second highest Employment to population ratio(%) of Lower middle income?
Your answer should be compact. 0.83. What is the difference between the highest and the second highest Employment to population ratio(%) of Chile?
Your response must be concise. 3.8. What is the difference between the highest and the second highest Employment to population ratio(%) in Gabon?
Provide a short and direct response. 0.5. What is the difference between the highest and the lowest Employment to population ratio(%) of Lower middle income?
Provide a short and direct response. 1.74. What is the difference between the highest and the lowest Employment to population ratio(%) in Malawi?
Offer a terse response. 20.8. 